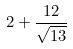Convert formula to latex. <formula><loc_0><loc_0><loc_500><loc_500>2 + \frac { 1 2 } { \sqrt { 1 3 } }</formula> 